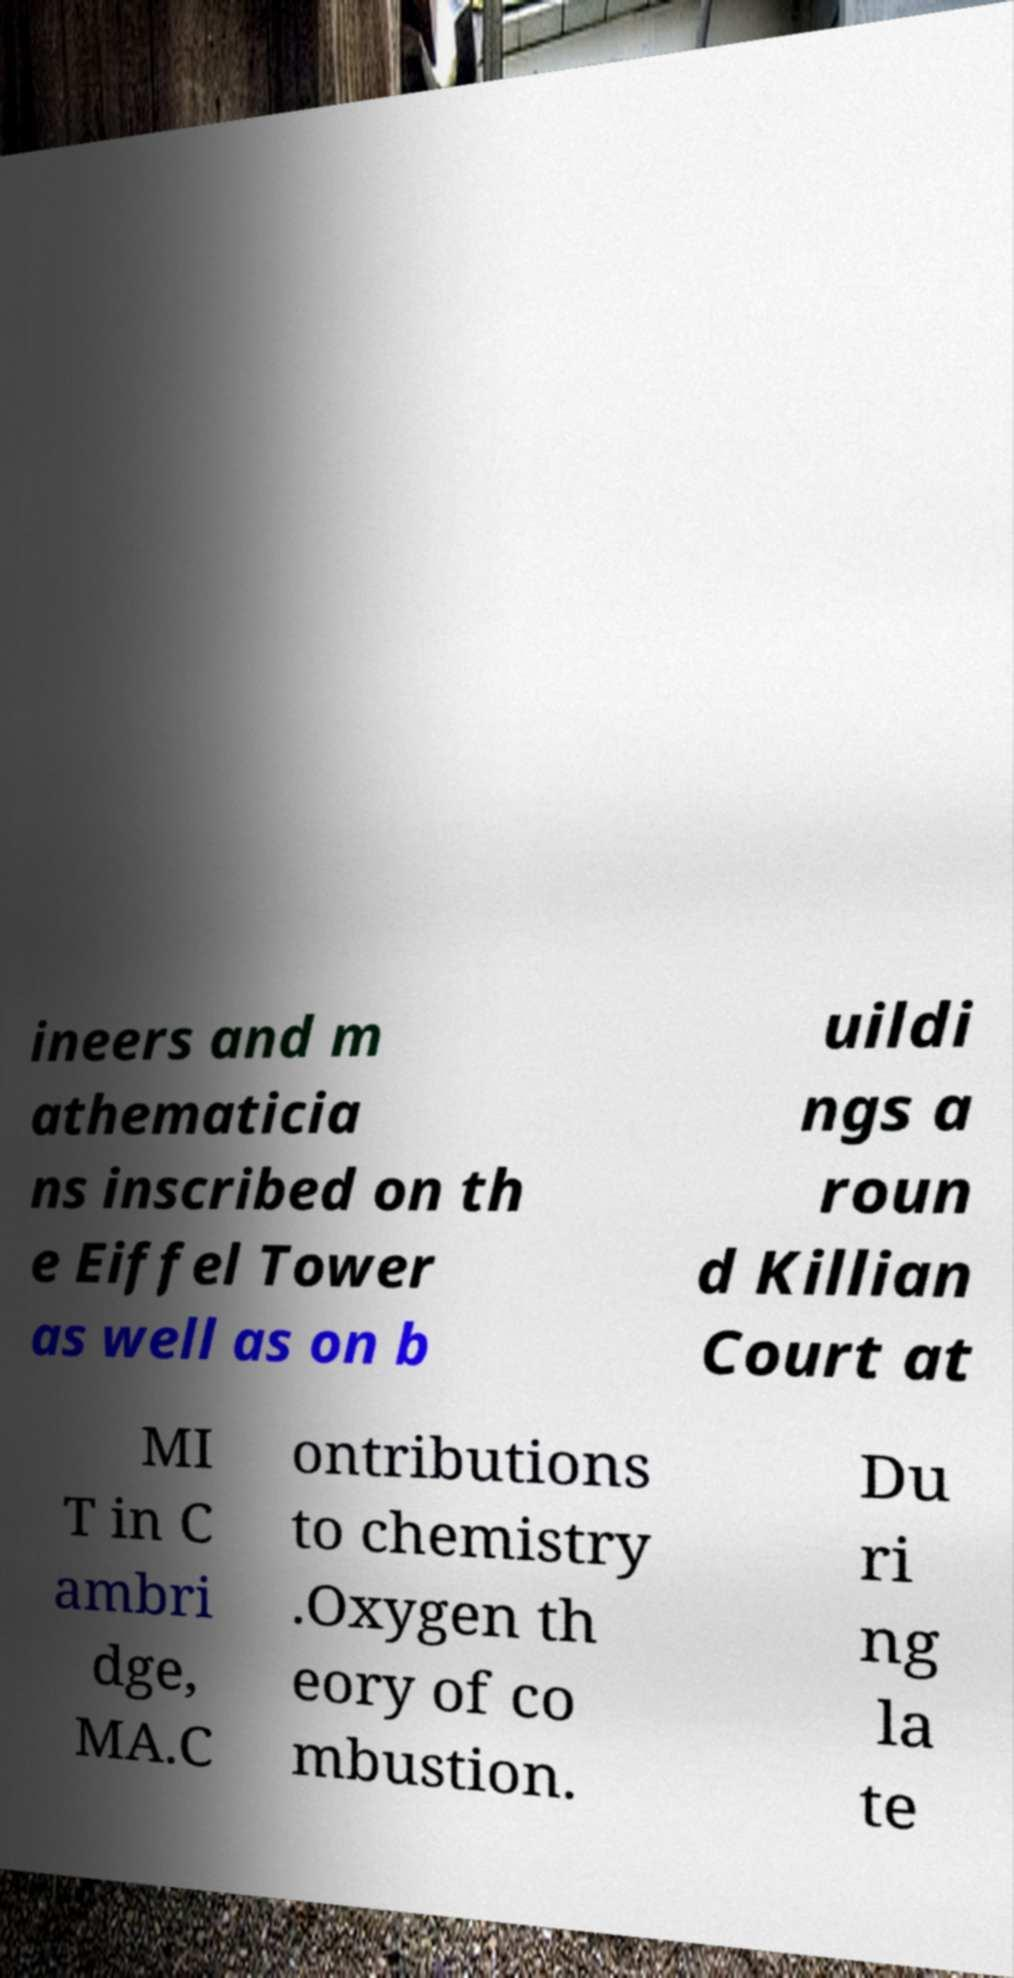Please identify and transcribe the text found in this image. ineers and m athematicia ns inscribed on th e Eiffel Tower as well as on b uildi ngs a roun d Killian Court at MI T in C ambri dge, MA.C ontributions to chemistry .Oxygen th eory of co mbustion. Du ri ng la te 